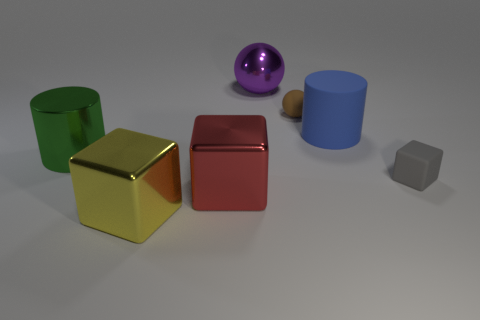Subtract all big yellow cubes. How many cubes are left? 2 Subtract all blue cylinders. How many cylinders are left? 1 Add 3 small metal blocks. How many objects exist? 10 Subtract 1 blocks. How many blocks are left? 2 Subtract all spheres. How many objects are left? 5 Subtract all purple blocks. Subtract all cyan balls. How many blocks are left? 3 Subtract all cyan cylinders. How many cyan cubes are left? 0 Subtract all tiny metallic things. Subtract all purple spheres. How many objects are left? 6 Add 5 brown rubber spheres. How many brown rubber spheres are left? 6 Add 4 red shiny cubes. How many red shiny cubes exist? 5 